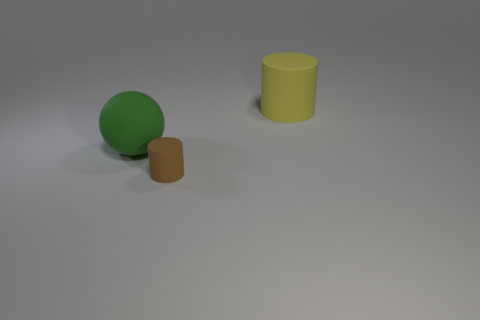Add 3 brown matte objects. How many objects exist? 6 Subtract all cylinders. How many objects are left? 1 Subtract 0 cyan spheres. How many objects are left? 3 Subtract all cyan cylinders. Subtract all green spheres. How many cylinders are left? 2 Subtract all green balls. Subtract all small matte cylinders. How many objects are left? 1 Add 3 tiny cylinders. How many tiny cylinders are left? 4 Add 3 tiny red objects. How many tiny red objects exist? 3 